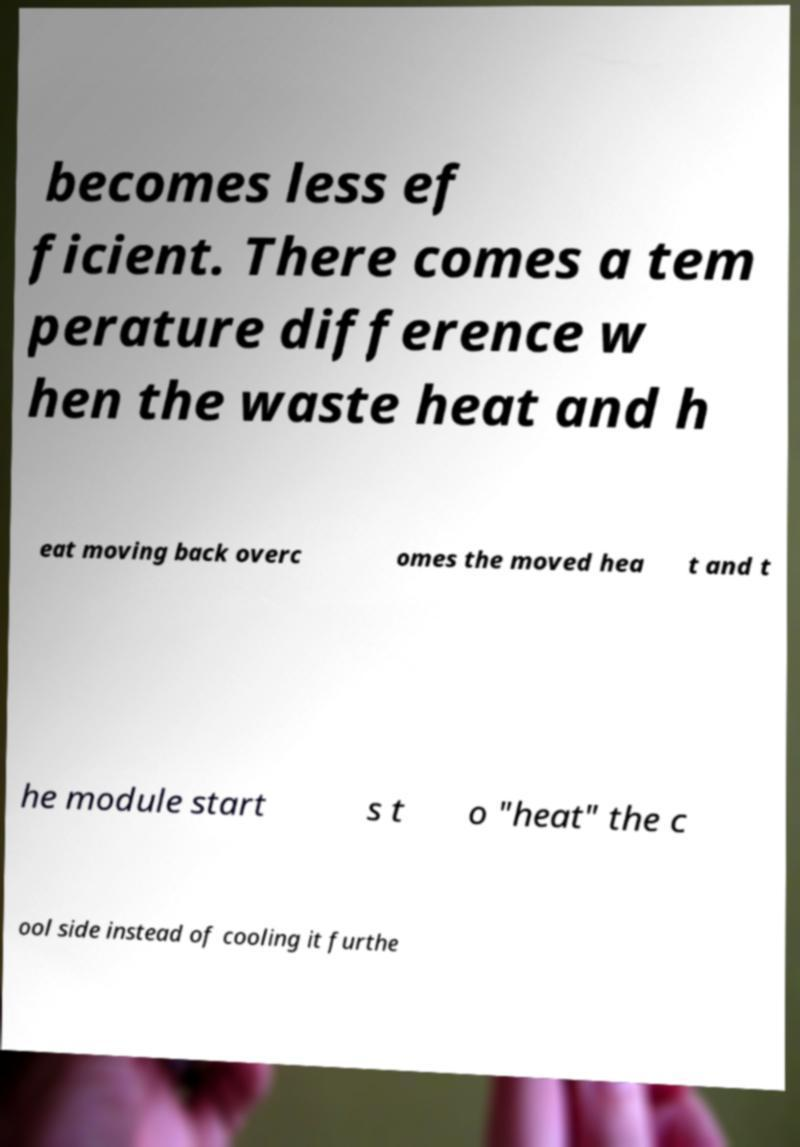There's text embedded in this image that I need extracted. Can you transcribe it verbatim? becomes less ef ficient. There comes a tem perature difference w hen the waste heat and h eat moving back overc omes the moved hea t and t he module start s t o "heat" the c ool side instead of cooling it furthe 